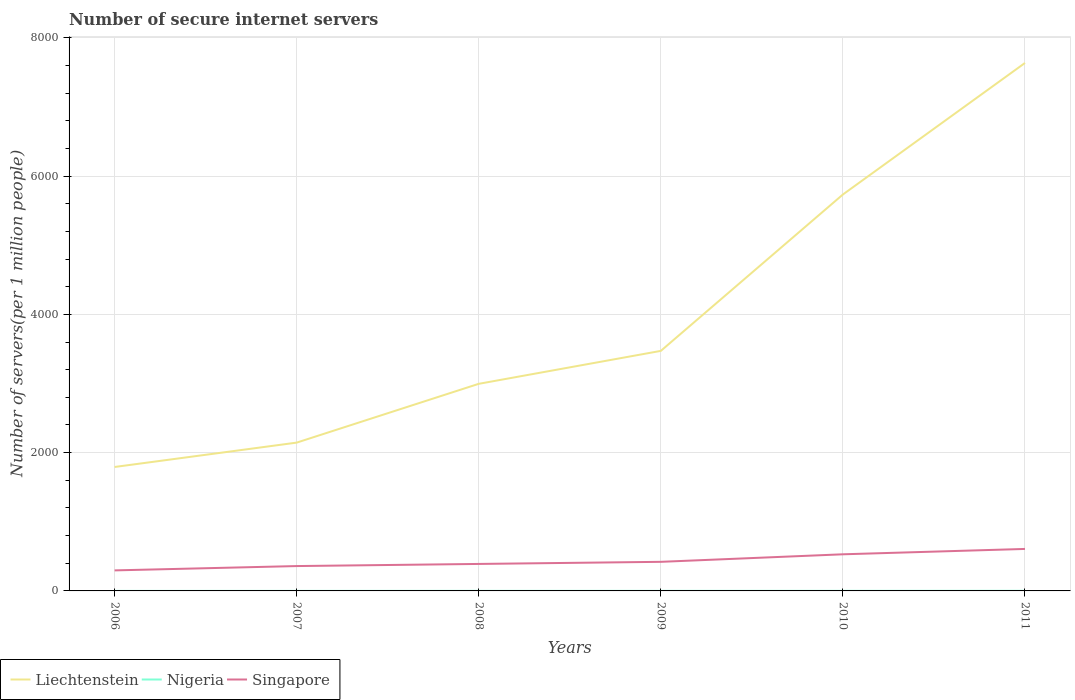How many different coloured lines are there?
Your answer should be very brief. 3. Does the line corresponding to Singapore intersect with the line corresponding to Liechtenstein?
Your answer should be compact. No. Is the number of lines equal to the number of legend labels?
Ensure brevity in your answer.  Yes. Across all years, what is the maximum number of secure internet servers in Nigeria?
Make the answer very short. 0.25. What is the total number of secure internet servers in Singapore in the graph?
Ensure brevity in your answer.  -30.75. What is the difference between the highest and the second highest number of secure internet servers in Liechtenstein?
Your answer should be compact. 5843.32. What is the difference between the highest and the lowest number of secure internet servers in Liechtenstein?
Your answer should be compact. 2. Is the number of secure internet servers in Singapore strictly greater than the number of secure internet servers in Nigeria over the years?
Ensure brevity in your answer.  No. How many lines are there?
Keep it short and to the point. 3. How many legend labels are there?
Ensure brevity in your answer.  3. What is the title of the graph?
Offer a very short reply. Number of secure internet servers. What is the label or title of the X-axis?
Offer a very short reply. Years. What is the label or title of the Y-axis?
Provide a short and direct response. Number of servers(per 1 million people). What is the Number of servers(per 1 million people) in Liechtenstein in 2006?
Ensure brevity in your answer.  1792.78. What is the Number of servers(per 1 million people) in Nigeria in 2006?
Ensure brevity in your answer.  0.25. What is the Number of servers(per 1 million people) in Singapore in 2006?
Your answer should be very brief. 296.95. What is the Number of servers(per 1 million people) of Liechtenstein in 2007?
Make the answer very short. 2145.01. What is the Number of servers(per 1 million people) of Nigeria in 2007?
Offer a terse response. 0.49. What is the Number of servers(per 1 million people) of Singapore in 2007?
Keep it short and to the point. 359.59. What is the Number of servers(per 1 million people) of Liechtenstein in 2008?
Offer a very short reply. 2995.44. What is the Number of servers(per 1 million people) of Nigeria in 2008?
Your answer should be compact. 0.79. What is the Number of servers(per 1 million people) of Singapore in 2008?
Your response must be concise. 390.34. What is the Number of servers(per 1 million people) of Liechtenstein in 2009?
Offer a terse response. 3471.84. What is the Number of servers(per 1 million people) in Nigeria in 2009?
Make the answer very short. 0.81. What is the Number of servers(per 1 million people) of Singapore in 2009?
Ensure brevity in your answer.  420.84. What is the Number of servers(per 1 million people) of Liechtenstein in 2010?
Offer a very short reply. 5733.82. What is the Number of servers(per 1 million people) of Nigeria in 2010?
Offer a very short reply. 1.2. What is the Number of servers(per 1 million people) of Singapore in 2010?
Keep it short and to the point. 529.67. What is the Number of servers(per 1 million people) in Liechtenstein in 2011?
Your response must be concise. 7636.09. What is the Number of servers(per 1 million people) of Nigeria in 2011?
Provide a succinct answer. 1.68. What is the Number of servers(per 1 million people) in Singapore in 2011?
Offer a terse response. 607.29. Across all years, what is the maximum Number of servers(per 1 million people) in Liechtenstein?
Your answer should be compact. 7636.09. Across all years, what is the maximum Number of servers(per 1 million people) in Nigeria?
Offer a terse response. 1.68. Across all years, what is the maximum Number of servers(per 1 million people) in Singapore?
Your answer should be compact. 607.29. Across all years, what is the minimum Number of servers(per 1 million people) in Liechtenstein?
Make the answer very short. 1792.78. Across all years, what is the minimum Number of servers(per 1 million people) in Nigeria?
Your answer should be very brief. 0.25. Across all years, what is the minimum Number of servers(per 1 million people) in Singapore?
Your answer should be compact. 296.95. What is the total Number of servers(per 1 million people) of Liechtenstein in the graph?
Give a very brief answer. 2.38e+04. What is the total Number of servers(per 1 million people) in Nigeria in the graph?
Make the answer very short. 5.22. What is the total Number of servers(per 1 million people) of Singapore in the graph?
Your answer should be compact. 2604.68. What is the difference between the Number of servers(per 1 million people) in Liechtenstein in 2006 and that in 2007?
Ensure brevity in your answer.  -352.24. What is the difference between the Number of servers(per 1 million people) of Nigeria in 2006 and that in 2007?
Your answer should be compact. -0.24. What is the difference between the Number of servers(per 1 million people) of Singapore in 2006 and that in 2007?
Keep it short and to the point. -62.64. What is the difference between the Number of servers(per 1 million people) in Liechtenstein in 2006 and that in 2008?
Your response must be concise. -1202.66. What is the difference between the Number of servers(per 1 million people) in Nigeria in 2006 and that in 2008?
Your response must be concise. -0.54. What is the difference between the Number of servers(per 1 million people) of Singapore in 2006 and that in 2008?
Your answer should be very brief. -93.39. What is the difference between the Number of servers(per 1 million people) of Liechtenstein in 2006 and that in 2009?
Keep it short and to the point. -1679.06. What is the difference between the Number of servers(per 1 million people) of Nigeria in 2006 and that in 2009?
Offer a terse response. -0.55. What is the difference between the Number of servers(per 1 million people) of Singapore in 2006 and that in 2009?
Ensure brevity in your answer.  -123.89. What is the difference between the Number of servers(per 1 million people) in Liechtenstein in 2006 and that in 2010?
Offer a terse response. -3941.04. What is the difference between the Number of servers(per 1 million people) in Nigeria in 2006 and that in 2010?
Make the answer very short. -0.95. What is the difference between the Number of servers(per 1 million people) in Singapore in 2006 and that in 2010?
Your response must be concise. -232.72. What is the difference between the Number of servers(per 1 million people) of Liechtenstein in 2006 and that in 2011?
Your answer should be compact. -5843.32. What is the difference between the Number of servers(per 1 million people) in Nigeria in 2006 and that in 2011?
Ensure brevity in your answer.  -1.43. What is the difference between the Number of servers(per 1 million people) of Singapore in 2006 and that in 2011?
Offer a very short reply. -310.34. What is the difference between the Number of servers(per 1 million people) in Liechtenstein in 2007 and that in 2008?
Your answer should be compact. -850.42. What is the difference between the Number of servers(per 1 million people) in Nigeria in 2007 and that in 2008?
Offer a terse response. -0.3. What is the difference between the Number of servers(per 1 million people) in Singapore in 2007 and that in 2008?
Your answer should be compact. -30.75. What is the difference between the Number of servers(per 1 million people) in Liechtenstein in 2007 and that in 2009?
Make the answer very short. -1326.82. What is the difference between the Number of servers(per 1 million people) of Nigeria in 2007 and that in 2009?
Offer a very short reply. -0.32. What is the difference between the Number of servers(per 1 million people) of Singapore in 2007 and that in 2009?
Ensure brevity in your answer.  -61.26. What is the difference between the Number of servers(per 1 million people) of Liechtenstein in 2007 and that in 2010?
Ensure brevity in your answer.  -3588.8. What is the difference between the Number of servers(per 1 million people) in Nigeria in 2007 and that in 2010?
Give a very brief answer. -0.71. What is the difference between the Number of servers(per 1 million people) of Singapore in 2007 and that in 2010?
Your response must be concise. -170.09. What is the difference between the Number of servers(per 1 million people) of Liechtenstein in 2007 and that in 2011?
Offer a very short reply. -5491.08. What is the difference between the Number of servers(per 1 million people) in Nigeria in 2007 and that in 2011?
Your response must be concise. -1.19. What is the difference between the Number of servers(per 1 million people) in Singapore in 2007 and that in 2011?
Your response must be concise. -247.7. What is the difference between the Number of servers(per 1 million people) in Liechtenstein in 2008 and that in 2009?
Offer a very short reply. -476.4. What is the difference between the Number of servers(per 1 million people) of Nigeria in 2008 and that in 2009?
Offer a terse response. -0.01. What is the difference between the Number of servers(per 1 million people) of Singapore in 2008 and that in 2009?
Provide a short and direct response. -30.51. What is the difference between the Number of servers(per 1 million people) in Liechtenstein in 2008 and that in 2010?
Give a very brief answer. -2738.38. What is the difference between the Number of servers(per 1 million people) in Nigeria in 2008 and that in 2010?
Offer a very short reply. -0.4. What is the difference between the Number of servers(per 1 million people) of Singapore in 2008 and that in 2010?
Your answer should be very brief. -139.34. What is the difference between the Number of servers(per 1 million people) of Liechtenstein in 2008 and that in 2011?
Keep it short and to the point. -4640.66. What is the difference between the Number of servers(per 1 million people) of Nigeria in 2008 and that in 2011?
Make the answer very short. -0.89. What is the difference between the Number of servers(per 1 million people) of Singapore in 2008 and that in 2011?
Provide a succinct answer. -216.95. What is the difference between the Number of servers(per 1 million people) of Liechtenstein in 2009 and that in 2010?
Offer a very short reply. -2261.98. What is the difference between the Number of servers(per 1 million people) in Nigeria in 2009 and that in 2010?
Offer a very short reply. -0.39. What is the difference between the Number of servers(per 1 million people) in Singapore in 2009 and that in 2010?
Your response must be concise. -108.83. What is the difference between the Number of servers(per 1 million people) in Liechtenstein in 2009 and that in 2011?
Make the answer very short. -4164.26. What is the difference between the Number of servers(per 1 million people) in Nigeria in 2009 and that in 2011?
Your answer should be compact. -0.87. What is the difference between the Number of servers(per 1 million people) in Singapore in 2009 and that in 2011?
Offer a very short reply. -186.44. What is the difference between the Number of servers(per 1 million people) of Liechtenstein in 2010 and that in 2011?
Keep it short and to the point. -1902.28. What is the difference between the Number of servers(per 1 million people) of Nigeria in 2010 and that in 2011?
Give a very brief answer. -0.48. What is the difference between the Number of servers(per 1 million people) in Singapore in 2010 and that in 2011?
Ensure brevity in your answer.  -77.61. What is the difference between the Number of servers(per 1 million people) of Liechtenstein in 2006 and the Number of servers(per 1 million people) of Nigeria in 2007?
Provide a succinct answer. 1792.29. What is the difference between the Number of servers(per 1 million people) of Liechtenstein in 2006 and the Number of servers(per 1 million people) of Singapore in 2007?
Provide a succinct answer. 1433.19. What is the difference between the Number of servers(per 1 million people) in Nigeria in 2006 and the Number of servers(per 1 million people) in Singapore in 2007?
Make the answer very short. -359.34. What is the difference between the Number of servers(per 1 million people) of Liechtenstein in 2006 and the Number of servers(per 1 million people) of Nigeria in 2008?
Your answer should be compact. 1791.98. What is the difference between the Number of servers(per 1 million people) of Liechtenstein in 2006 and the Number of servers(per 1 million people) of Singapore in 2008?
Your response must be concise. 1402.44. What is the difference between the Number of servers(per 1 million people) in Nigeria in 2006 and the Number of servers(per 1 million people) in Singapore in 2008?
Ensure brevity in your answer.  -390.09. What is the difference between the Number of servers(per 1 million people) of Liechtenstein in 2006 and the Number of servers(per 1 million people) of Nigeria in 2009?
Provide a short and direct response. 1791.97. What is the difference between the Number of servers(per 1 million people) in Liechtenstein in 2006 and the Number of servers(per 1 million people) in Singapore in 2009?
Ensure brevity in your answer.  1371.93. What is the difference between the Number of servers(per 1 million people) in Nigeria in 2006 and the Number of servers(per 1 million people) in Singapore in 2009?
Your answer should be very brief. -420.59. What is the difference between the Number of servers(per 1 million people) in Liechtenstein in 2006 and the Number of servers(per 1 million people) in Nigeria in 2010?
Your answer should be compact. 1791.58. What is the difference between the Number of servers(per 1 million people) in Liechtenstein in 2006 and the Number of servers(per 1 million people) in Singapore in 2010?
Ensure brevity in your answer.  1263.1. What is the difference between the Number of servers(per 1 million people) in Nigeria in 2006 and the Number of servers(per 1 million people) in Singapore in 2010?
Give a very brief answer. -529.42. What is the difference between the Number of servers(per 1 million people) of Liechtenstein in 2006 and the Number of servers(per 1 million people) of Nigeria in 2011?
Give a very brief answer. 1791.1. What is the difference between the Number of servers(per 1 million people) in Liechtenstein in 2006 and the Number of servers(per 1 million people) in Singapore in 2011?
Provide a short and direct response. 1185.49. What is the difference between the Number of servers(per 1 million people) of Nigeria in 2006 and the Number of servers(per 1 million people) of Singapore in 2011?
Give a very brief answer. -607.04. What is the difference between the Number of servers(per 1 million people) of Liechtenstein in 2007 and the Number of servers(per 1 million people) of Nigeria in 2008?
Provide a succinct answer. 2144.22. What is the difference between the Number of servers(per 1 million people) in Liechtenstein in 2007 and the Number of servers(per 1 million people) in Singapore in 2008?
Your answer should be compact. 1754.68. What is the difference between the Number of servers(per 1 million people) in Nigeria in 2007 and the Number of servers(per 1 million people) in Singapore in 2008?
Your answer should be very brief. -389.85. What is the difference between the Number of servers(per 1 million people) in Liechtenstein in 2007 and the Number of servers(per 1 million people) in Nigeria in 2009?
Give a very brief answer. 2144.21. What is the difference between the Number of servers(per 1 million people) of Liechtenstein in 2007 and the Number of servers(per 1 million people) of Singapore in 2009?
Ensure brevity in your answer.  1724.17. What is the difference between the Number of servers(per 1 million people) of Nigeria in 2007 and the Number of servers(per 1 million people) of Singapore in 2009?
Ensure brevity in your answer.  -420.35. What is the difference between the Number of servers(per 1 million people) in Liechtenstein in 2007 and the Number of servers(per 1 million people) in Nigeria in 2010?
Provide a short and direct response. 2143.82. What is the difference between the Number of servers(per 1 million people) of Liechtenstein in 2007 and the Number of servers(per 1 million people) of Singapore in 2010?
Make the answer very short. 1615.34. What is the difference between the Number of servers(per 1 million people) of Nigeria in 2007 and the Number of servers(per 1 million people) of Singapore in 2010?
Provide a short and direct response. -529.19. What is the difference between the Number of servers(per 1 million people) in Liechtenstein in 2007 and the Number of servers(per 1 million people) in Nigeria in 2011?
Offer a very short reply. 2143.34. What is the difference between the Number of servers(per 1 million people) in Liechtenstein in 2007 and the Number of servers(per 1 million people) in Singapore in 2011?
Your answer should be very brief. 1537.73. What is the difference between the Number of servers(per 1 million people) in Nigeria in 2007 and the Number of servers(per 1 million people) in Singapore in 2011?
Make the answer very short. -606.8. What is the difference between the Number of servers(per 1 million people) in Liechtenstein in 2008 and the Number of servers(per 1 million people) in Nigeria in 2009?
Your answer should be very brief. 2994.63. What is the difference between the Number of servers(per 1 million people) of Liechtenstein in 2008 and the Number of servers(per 1 million people) of Singapore in 2009?
Give a very brief answer. 2574.59. What is the difference between the Number of servers(per 1 million people) in Nigeria in 2008 and the Number of servers(per 1 million people) in Singapore in 2009?
Provide a short and direct response. -420.05. What is the difference between the Number of servers(per 1 million people) of Liechtenstein in 2008 and the Number of servers(per 1 million people) of Nigeria in 2010?
Give a very brief answer. 2994.24. What is the difference between the Number of servers(per 1 million people) in Liechtenstein in 2008 and the Number of servers(per 1 million people) in Singapore in 2010?
Keep it short and to the point. 2465.76. What is the difference between the Number of servers(per 1 million people) in Nigeria in 2008 and the Number of servers(per 1 million people) in Singapore in 2010?
Ensure brevity in your answer.  -528.88. What is the difference between the Number of servers(per 1 million people) in Liechtenstein in 2008 and the Number of servers(per 1 million people) in Nigeria in 2011?
Provide a short and direct response. 2993.76. What is the difference between the Number of servers(per 1 million people) of Liechtenstein in 2008 and the Number of servers(per 1 million people) of Singapore in 2011?
Ensure brevity in your answer.  2388.15. What is the difference between the Number of servers(per 1 million people) in Nigeria in 2008 and the Number of servers(per 1 million people) in Singapore in 2011?
Keep it short and to the point. -606.49. What is the difference between the Number of servers(per 1 million people) of Liechtenstein in 2009 and the Number of servers(per 1 million people) of Nigeria in 2010?
Your response must be concise. 3470.64. What is the difference between the Number of servers(per 1 million people) in Liechtenstein in 2009 and the Number of servers(per 1 million people) in Singapore in 2010?
Your answer should be compact. 2942.16. What is the difference between the Number of servers(per 1 million people) in Nigeria in 2009 and the Number of servers(per 1 million people) in Singapore in 2010?
Give a very brief answer. -528.87. What is the difference between the Number of servers(per 1 million people) in Liechtenstein in 2009 and the Number of servers(per 1 million people) in Nigeria in 2011?
Your answer should be very brief. 3470.16. What is the difference between the Number of servers(per 1 million people) of Liechtenstein in 2009 and the Number of servers(per 1 million people) of Singapore in 2011?
Ensure brevity in your answer.  2864.55. What is the difference between the Number of servers(per 1 million people) of Nigeria in 2009 and the Number of servers(per 1 million people) of Singapore in 2011?
Your answer should be very brief. -606.48. What is the difference between the Number of servers(per 1 million people) of Liechtenstein in 2010 and the Number of servers(per 1 million people) of Nigeria in 2011?
Provide a succinct answer. 5732.14. What is the difference between the Number of servers(per 1 million people) of Liechtenstein in 2010 and the Number of servers(per 1 million people) of Singapore in 2011?
Your response must be concise. 5126.53. What is the difference between the Number of servers(per 1 million people) of Nigeria in 2010 and the Number of servers(per 1 million people) of Singapore in 2011?
Give a very brief answer. -606.09. What is the average Number of servers(per 1 million people) of Liechtenstein per year?
Offer a terse response. 3962.5. What is the average Number of servers(per 1 million people) of Nigeria per year?
Offer a terse response. 0.87. What is the average Number of servers(per 1 million people) in Singapore per year?
Ensure brevity in your answer.  434.11. In the year 2006, what is the difference between the Number of servers(per 1 million people) in Liechtenstein and Number of servers(per 1 million people) in Nigeria?
Provide a short and direct response. 1792.53. In the year 2006, what is the difference between the Number of servers(per 1 million people) in Liechtenstein and Number of servers(per 1 million people) in Singapore?
Your response must be concise. 1495.83. In the year 2006, what is the difference between the Number of servers(per 1 million people) of Nigeria and Number of servers(per 1 million people) of Singapore?
Offer a terse response. -296.7. In the year 2007, what is the difference between the Number of servers(per 1 million people) in Liechtenstein and Number of servers(per 1 million people) in Nigeria?
Your answer should be very brief. 2144.53. In the year 2007, what is the difference between the Number of servers(per 1 million people) of Liechtenstein and Number of servers(per 1 million people) of Singapore?
Your answer should be compact. 1785.43. In the year 2007, what is the difference between the Number of servers(per 1 million people) in Nigeria and Number of servers(per 1 million people) in Singapore?
Give a very brief answer. -359.1. In the year 2008, what is the difference between the Number of servers(per 1 million people) in Liechtenstein and Number of servers(per 1 million people) in Nigeria?
Give a very brief answer. 2994.64. In the year 2008, what is the difference between the Number of servers(per 1 million people) of Liechtenstein and Number of servers(per 1 million people) of Singapore?
Ensure brevity in your answer.  2605.1. In the year 2008, what is the difference between the Number of servers(per 1 million people) in Nigeria and Number of servers(per 1 million people) in Singapore?
Your answer should be compact. -389.54. In the year 2009, what is the difference between the Number of servers(per 1 million people) in Liechtenstein and Number of servers(per 1 million people) in Nigeria?
Keep it short and to the point. 3471.03. In the year 2009, what is the difference between the Number of servers(per 1 million people) in Liechtenstein and Number of servers(per 1 million people) in Singapore?
Ensure brevity in your answer.  3050.99. In the year 2009, what is the difference between the Number of servers(per 1 million people) of Nigeria and Number of servers(per 1 million people) of Singapore?
Provide a succinct answer. -420.04. In the year 2010, what is the difference between the Number of servers(per 1 million people) of Liechtenstein and Number of servers(per 1 million people) of Nigeria?
Offer a very short reply. 5732.62. In the year 2010, what is the difference between the Number of servers(per 1 million people) in Liechtenstein and Number of servers(per 1 million people) in Singapore?
Provide a succinct answer. 5204.14. In the year 2010, what is the difference between the Number of servers(per 1 million people) in Nigeria and Number of servers(per 1 million people) in Singapore?
Ensure brevity in your answer.  -528.48. In the year 2011, what is the difference between the Number of servers(per 1 million people) of Liechtenstein and Number of servers(per 1 million people) of Nigeria?
Make the answer very short. 7634.42. In the year 2011, what is the difference between the Number of servers(per 1 million people) in Liechtenstein and Number of servers(per 1 million people) in Singapore?
Keep it short and to the point. 7028.81. In the year 2011, what is the difference between the Number of servers(per 1 million people) in Nigeria and Number of servers(per 1 million people) in Singapore?
Provide a succinct answer. -605.61. What is the ratio of the Number of servers(per 1 million people) of Liechtenstein in 2006 to that in 2007?
Your answer should be compact. 0.84. What is the ratio of the Number of servers(per 1 million people) in Nigeria in 2006 to that in 2007?
Your answer should be very brief. 0.51. What is the ratio of the Number of servers(per 1 million people) in Singapore in 2006 to that in 2007?
Offer a very short reply. 0.83. What is the ratio of the Number of servers(per 1 million people) in Liechtenstein in 2006 to that in 2008?
Offer a very short reply. 0.6. What is the ratio of the Number of servers(per 1 million people) of Nigeria in 2006 to that in 2008?
Give a very brief answer. 0.32. What is the ratio of the Number of servers(per 1 million people) in Singapore in 2006 to that in 2008?
Your answer should be very brief. 0.76. What is the ratio of the Number of servers(per 1 million people) of Liechtenstein in 2006 to that in 2009?
Ensure brevity in your answer.  0.52. What is the ratio of the Number of servers(per 1 million people) in Nigeria in 2006 to that in 2009?
Keep it short and to the point. 0.31. What is the ratio of the Number of servers(per 1 million people) of Singapore in 2006 to that in 2009?
Provide a succinct answer. 0.71. What is the ratio of the Number of servers(per 1 million people) in Liechtenstein in 2006 to that in 2010?
Give a very brief answer. 0.31. What is the ratio of the Number of servers(per 1 million people) in Nigeria in 2006 to that in 2010?
Offer a terse response. 0.21. What is the ratio of the Number of servers(per 1 million people) of Singapore in 2006 to that in 2010?
Keep it short and to the point. 0.56. What is the ratio of the Number of servers(per 1 million people) of Liechtenstein in 2006 to that in 2011?
Ensure brevity in your answer.  0.23. What is the ratio of the Number of servers(per 1 million people) in Nigeria in 2006 to that in 2011?
Your response must be concise. 0.15. What is the ratio of the Number of servers(per 1 million people) of Singapore in 2006 to that in 2011?
Give a very brief answer. 0.49. What is the ratio of the Number of servers(per 1 million people) in Liechtenstein in 2007 to that in 2008?
Offer a very short reply. 0.72. What is the ratio of the Number of servers(per 1 million people) of Nigeria in 2007 to that in 2008?
Offer a terse response. 0.62. What is the ratio of the Number of servers(per 1 million people) of Singapore in 2007 to that in 2008?
Give a very brief answer. 0.92. What is the ratio of the Number of servers(per 1 million people) of Liechtenstein in 2007 to that in 2009?
Offer a very short reply. 0.62. What is the ratio of the Number of servers(per 1 million people) in Nigeria in 2007 to that in 2009?
Your answer should be very brief. 0.61. What is the ratio of the Number of servers(per 1 million people) of Singapore in 2007 to that in 2009?
Provide a short and direct response. 0.85. What is the ratio of the Number of servers(per 1 million people) in Liechtenstein in 2007 to that in 2010?
Ensure brevity in your answer.  0.37. What is the ratio of the Number of servers(per 1 million people) in Nigeria in 2007 to that in 2010?
Provide a succinct answer. 0.41. What is the ratio of the Number of servers(per 1 million people) in Singapore in 2007 to that in 2010?
Provide a short and direct response. 0.68. What is the ratio of the Number of servers(per 1 million people) in Liechtenstein in 2007 to that in 2011?
Provide a short and direct response. 0.28. What is the ratio of the Number of servers(per 1 million people) in Nigeria in 2007 to that in 2011?
Make the answer very short. 0.29. What is the ratio of the Number of servers(per 1 million people) in Singapore in 2007 to that in 2011?
Provide a short and direct response. 0.59. What is the ratio of the Number of servers(per 1 million people) in Liechtenstein in 2008 to that in 2009?
Ensure brevity in your answer.  0.86. What is the ratio of the Number of servers(per 1 million people) of Singapore in 2008 to that in 2009?
Your answer should be compact. 0.93. What is the ratio of the Number of servers(per 1 million people) of Liechtenstein in 2008 to that in 2010?
Provide a short and direct response. 0.52. What is the ratio of the Number of servers(per 1 million people) of Nigeria in 2008 to that in 2010?
Ensure brevity in your answer.  0.66. What is the ratio of the Number of servers(per 1 million people) in Singapore in 2008 to that in 2010?
Offer a very short reply. 0.74. What is the ratio of the Number of servers(per 1 million people) of Liechtenstein in 2008 to that in 2011?
Make the answer very short. 0.39. What is the ratio of the Number of servers(per 1 million people) in Nigeria in 2008 to that in 2011?
Your answer should be very brief. 0.47. What is the ratio of the Number of servers(per 1 million people) in Singapore in 2008 to that in 2011?
Provide a succinct answer. 0.64. What is the ratio of the Number of servers(per 1 million people) of Liechtenstein in 2009 to that in 2010?
Make the answer very short. 0.61. What is the ratio of the Number of servers(per 1 million people) in Nigeria in 2009 to that in 2010?
Ensure brevity in your answer.  0.67. What is the ratio of the Number of servers(per 1 million people) in Singapore in 2009 to that in 2010?
Your response must be concise. 0.79. What is the ratio of the Number of servers(per 1 million people) of Liechtenstein in 2009 to that in 2011?
Offer a terse response. 0.45. What is the ratio of the Number of servers(per 1 million people) in Nigeria in 2009 to that in 2011?
Offer a very short reply. 0.48. What is the ratio of the Number of servers(per 1 million people) in Singapore in 2009 to that in 2011?
Provide a succinct answer. 0.69. What is the ratio of the Number of servers(per 1 million people) of Liechtenstein in 2010 to that in 2011?
Ensure brevity in your answer.  0.75. What is the ratio of the Number of servers(per 1 million people) in Nigeria in 2010 to that in 2011?
Offer a terse response. 0.71. What is the ratio of the Number of servers(per 1 million people) in Singapore in 2010 to that in 2011?
Offer a terse response. 0.87. What is the difference between the highest and the second highest Number of servers(per 1 million people) in Liechtenstein?
Offer a very short reply. 1902.28. What is the difference between the highest and the second highest Number of servers(per 1 million people) in Nigeria?
Your answer should be compact. 0.48. What is the difference between the highest and the second highest Number of servers(per 1 million people) in Singapore?
Give a very brief answer. 77.61. What is the difference between the highest and the lowest Number of servers(per 1 million people) in Liechtenstein?
Ensure brevity in your answer.  5843.32. What is the difference between the highest and the lowest Number of servers(per 1 million people) of Nigeria?
Provide a short and direct response. 1.43. What is the difference between the highest and the lowest Number of servers(per 1 million people) of Singapore?
Provide a short and direct response. 310.34. 